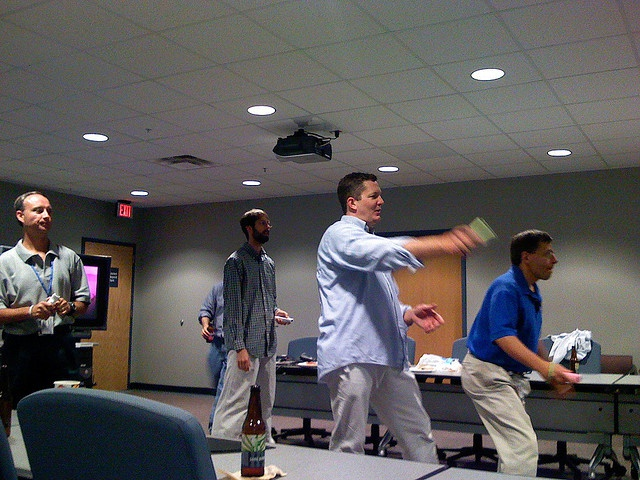Describe the objects in this image and their specific colors. I can see people in gray, lavender, and darkgray tones, chair in gray, black, and navy tones, people in gray, black, darkgray, and lightgray tones, people in gray, navy, darkgray, black, and maroon tones, and people in gray, black, and darkgray tones in this image. 